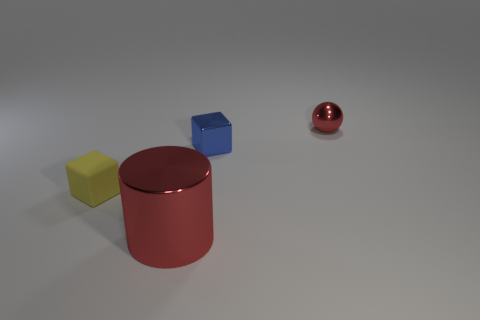Add 2 large shiny things. How many objects exist? 6 Subtract all balls. How many objects are left? 3 Subtract all big red metallic cylinders. Subtract all tiny cubes. How many objects are left? 1 Add 1 tiny matte cubes. How many tiny matte cubes are left? 2 Add 3 tiny blue metal spheres. How many tiny blue metal spheres exist? 3 Subtract 1 blue cubes. How many objects are left? 3 